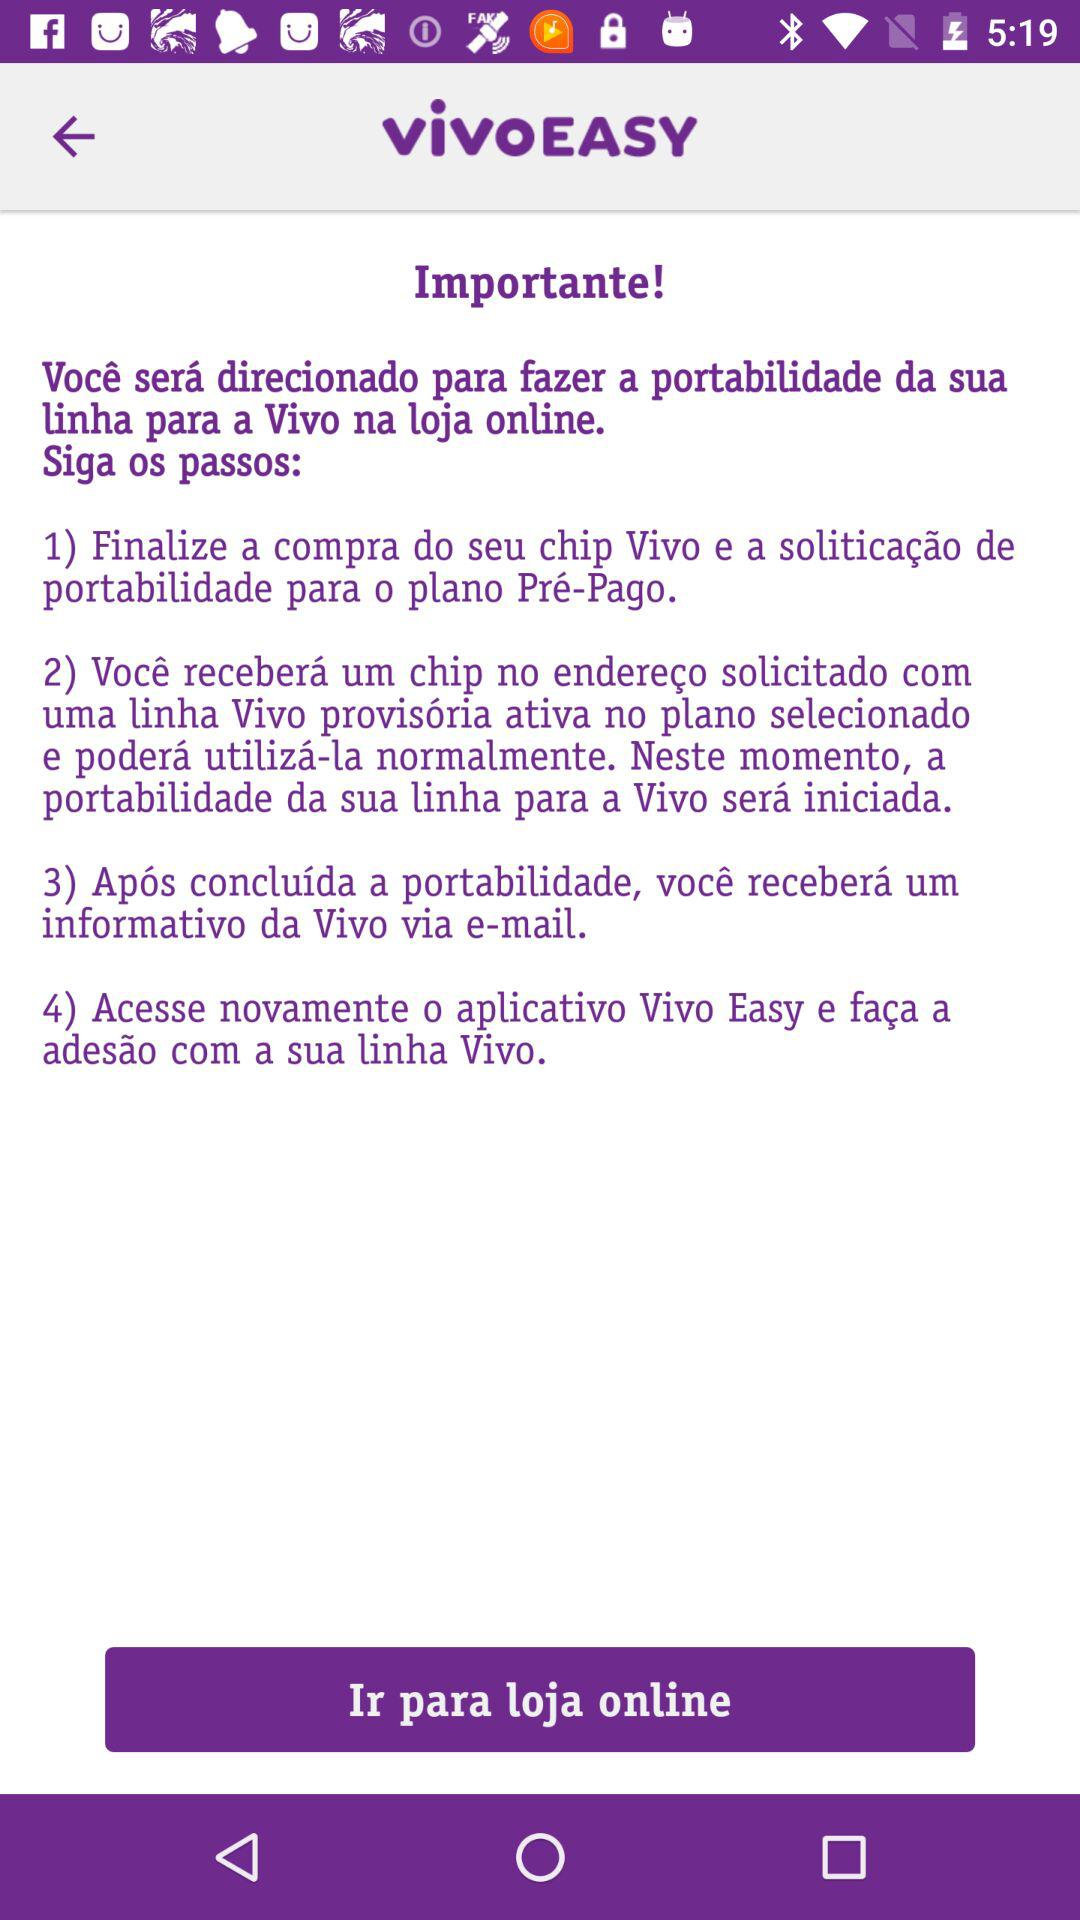How many steps are there to complete the portabilidade?
Answer the question using a single word or phrase. 4 